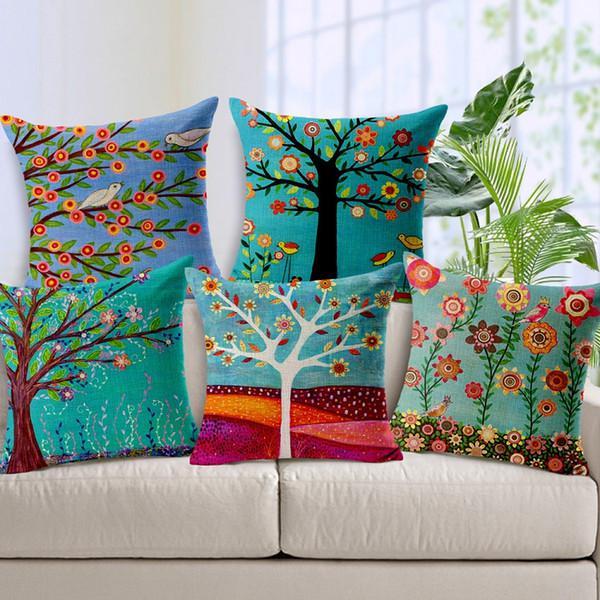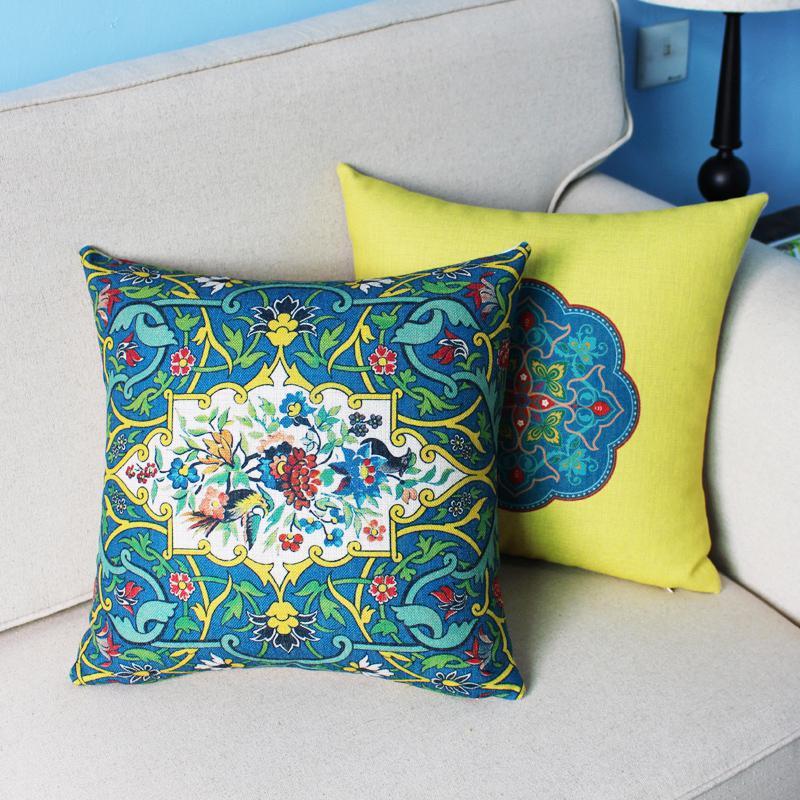The first image is the image on the left, the second image is the image on the right. Examine the images to the left and right. Is the description "there are two throw pillows in the right image" accurate? Answer yes or no. Yes. The first image is the image on the left, the second image is the image on the right. For the images shown, is this caption "There are five throw pillows in each picture on the left and two throw pillows in each picture on the right." true? Answer yes or no. Yes. 